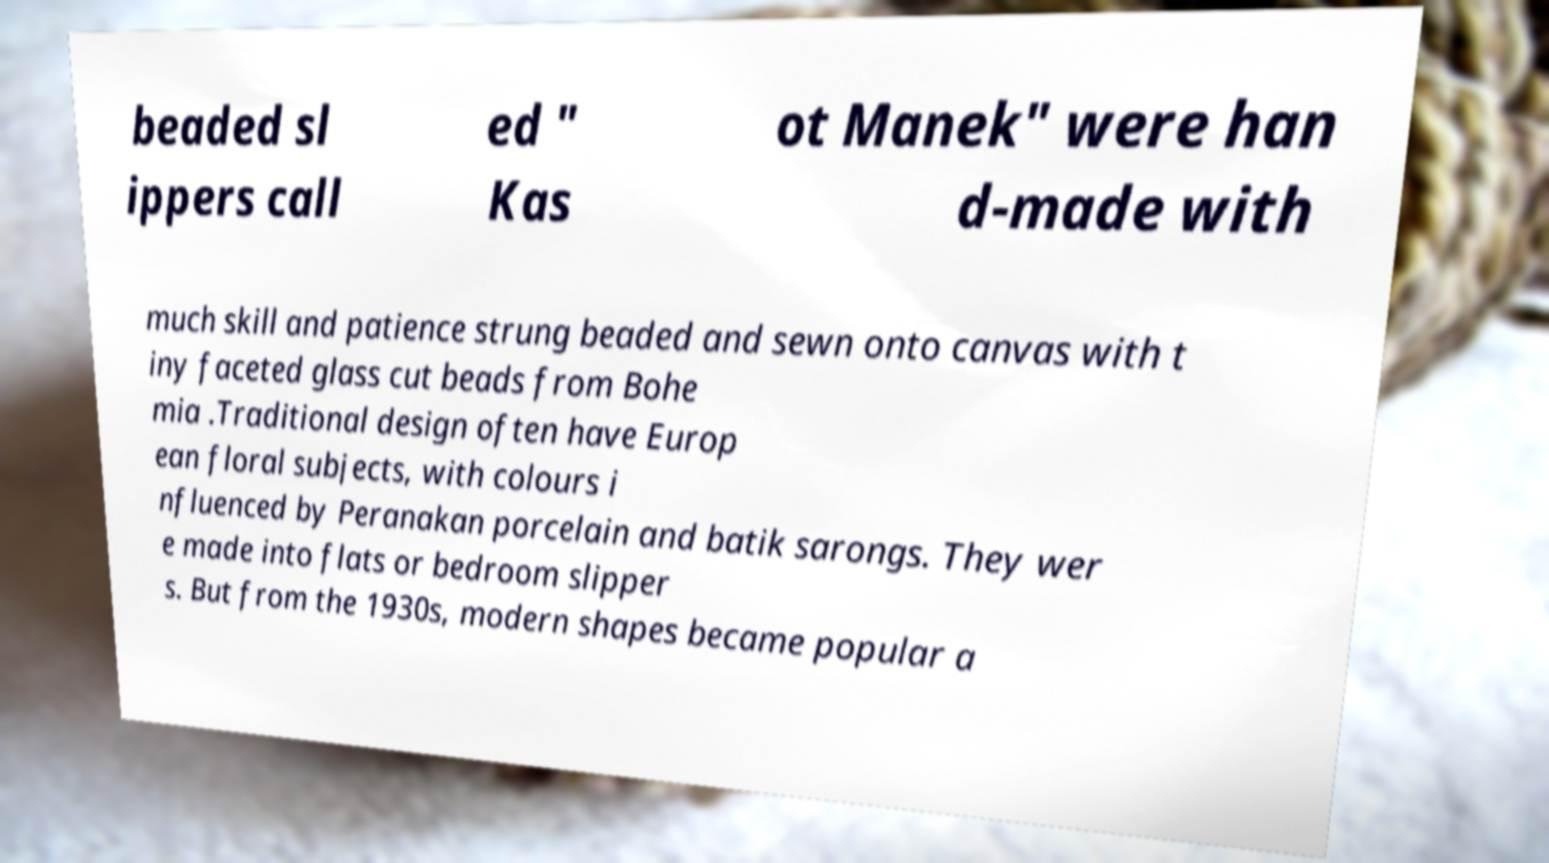What messages or text are displayed in this image? I need them in a readable, typed format. beaded sl ippers call ed " Kas ot Manek" were han d-made with much skill and patience strung beaded and sewn onto canvas with t iny faceted glass cut beads from Bohe mia .Traditional design often have Europ ean floral subjects, with colours i nfluenced by Peranakan porcelain and batik sarongs. They wer e made into flats or bedroom slipper s. But from the 1930s, modern shapes became popular a 